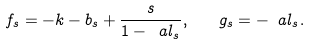<formula> <loc_0><loc_0><loc_500><loc_500>f _ { s } = - k - b _ { s } + \frac { s } { 1 - \ a l _ { s } } , \quad g _ { s } = - \ a l _ { s } .</formula> 